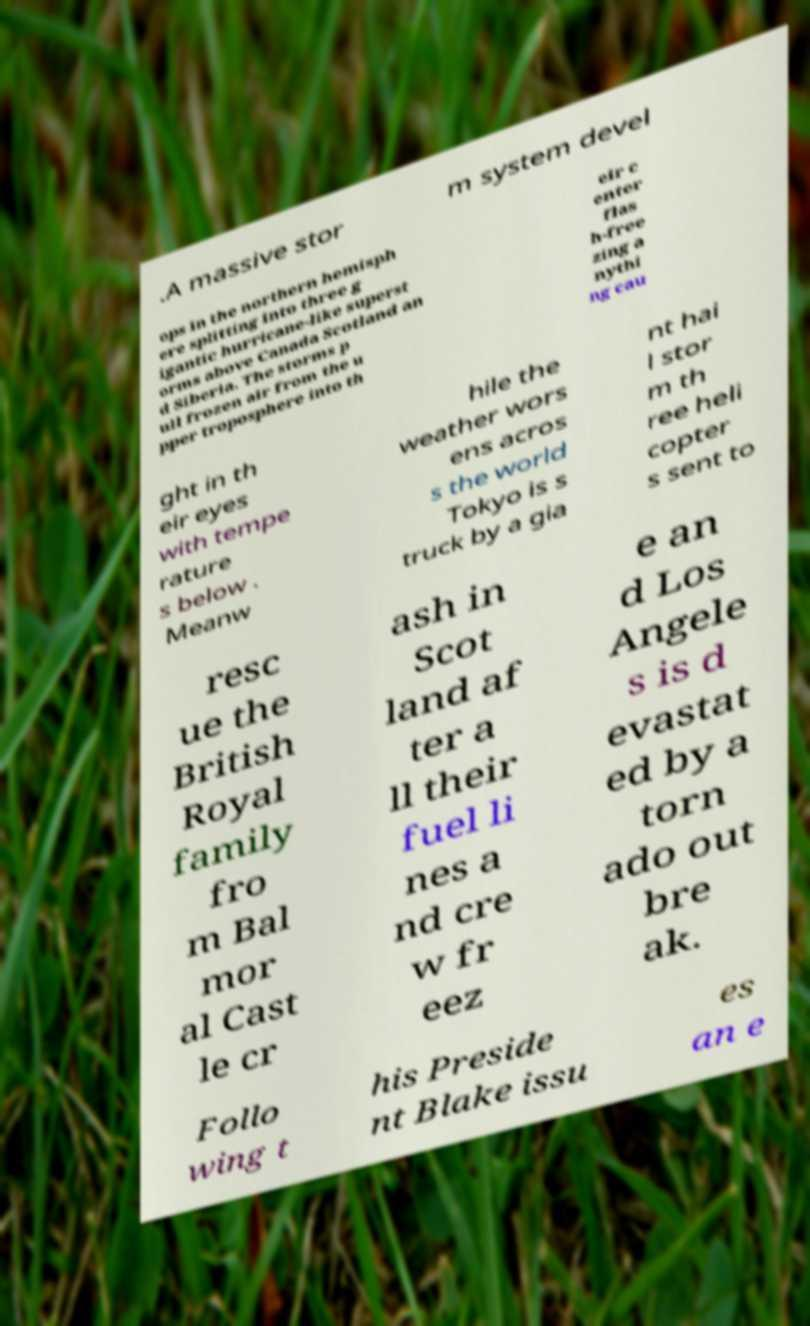For documentation purposes, I need the text within this image transcribed. Could you provide that? .A massive stor m system devel ops in the northern hemisph ere splitting into three g igantic hurricane-like superst orms above Canada Scotland an d Siberia. The storms p ull frozen air from the u pper troposphere into th eir c enter flas h-free zing a nythi ng cau ght in th eir eyes with tempe rature s below . Meanw hile the weather wors ens acros s the world Tokyo is s truck by a gia nt hai l stor m th ree heli copter s sent to resc ue the British Royal family fro m Bal mor al Cast le cr ash in Scot land af ter a ll their fuel li nes a nd cre w fr eez e an d Los Angele s is d evastat ed by a torn ado out bre ak. Follo wing t his Preside nt Blake issu es an e 